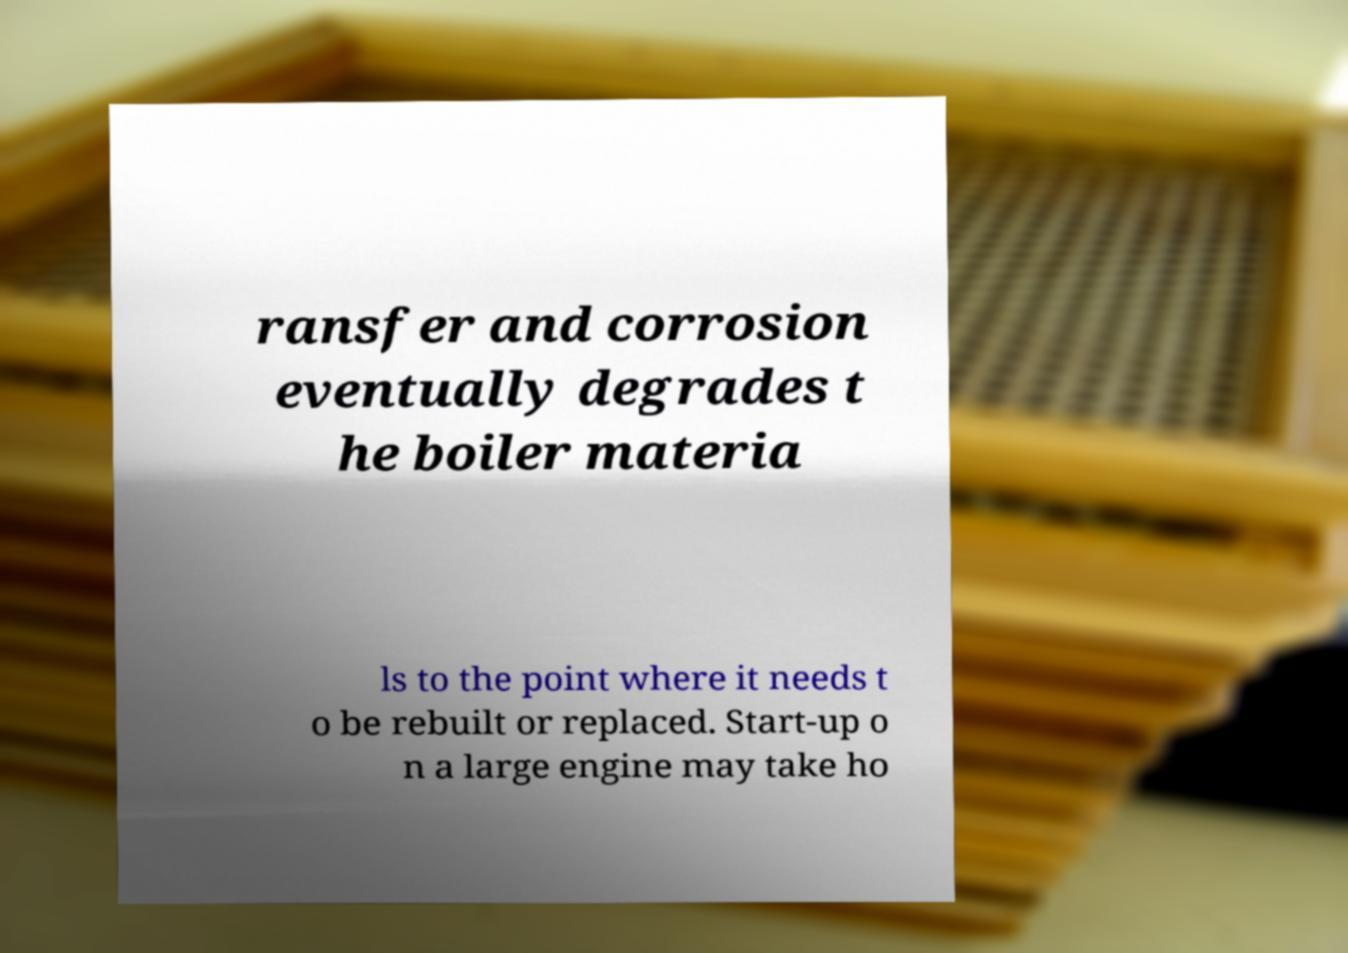Please read and relay the text visible in this image. What does it say? ransfer and corrosion eventually degrades t he boiler materia ls to the point where it needs t o be rebuilt or replaced. Start-up o n a large engine may take ho 